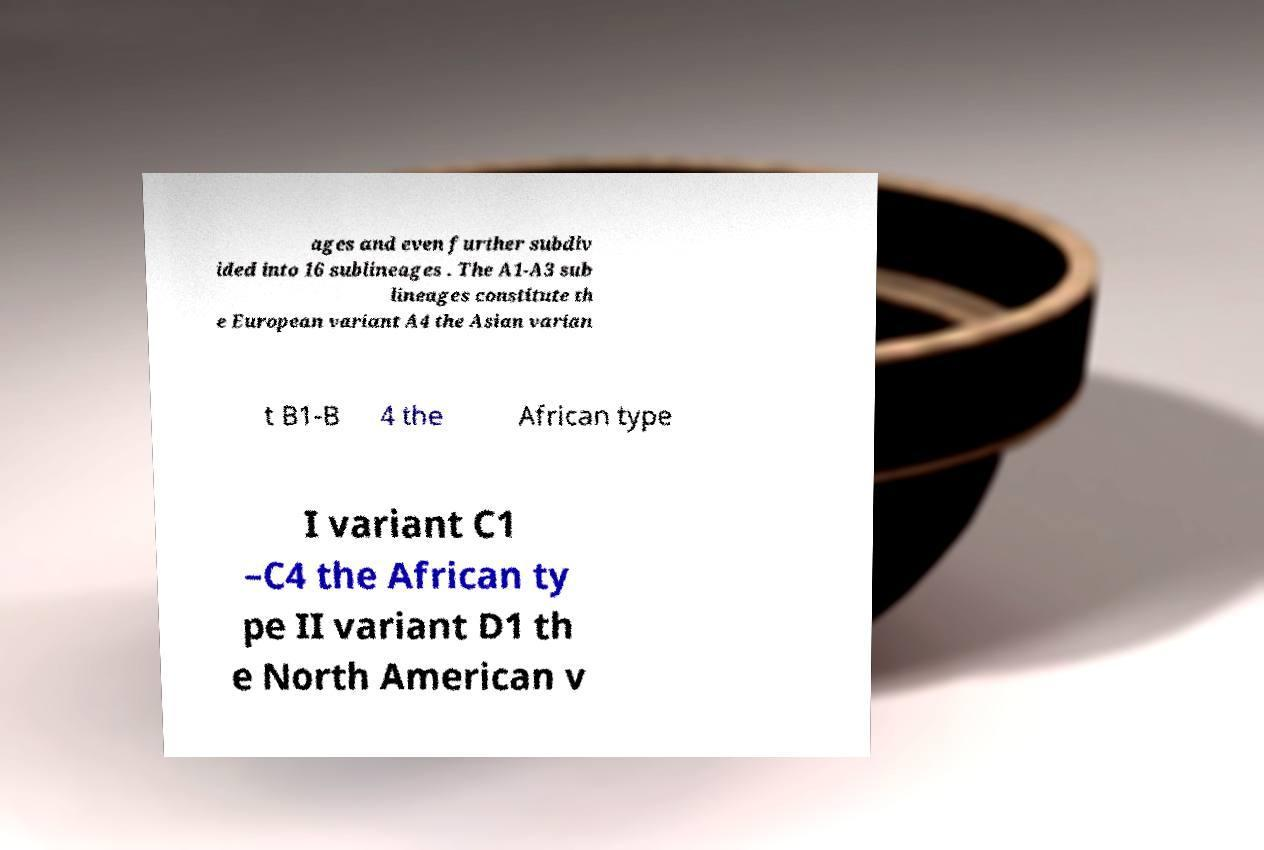I need the written content from this picture converted into text. Can you do that? ages and even further subdiv ided into 16 sublineages . The A1-A3 sub lineages constitute th e European variant A4 the Asian varian t B1-B 4 the African type I variant C1 –C4 the African ty pe II variant D1 th e North American v 